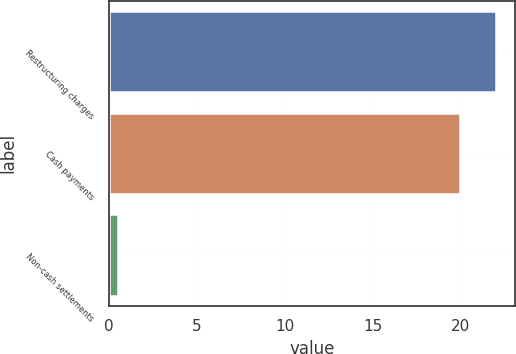<chart> <loc_0><loc_0><loc_500><loc_500><bar_chart><fcel>Restructuring charges<fcel>Cash payments<fcel>Non-cash settlements<nl><fcel>22<fcel>20<fcel>0.5<nl></chart> 